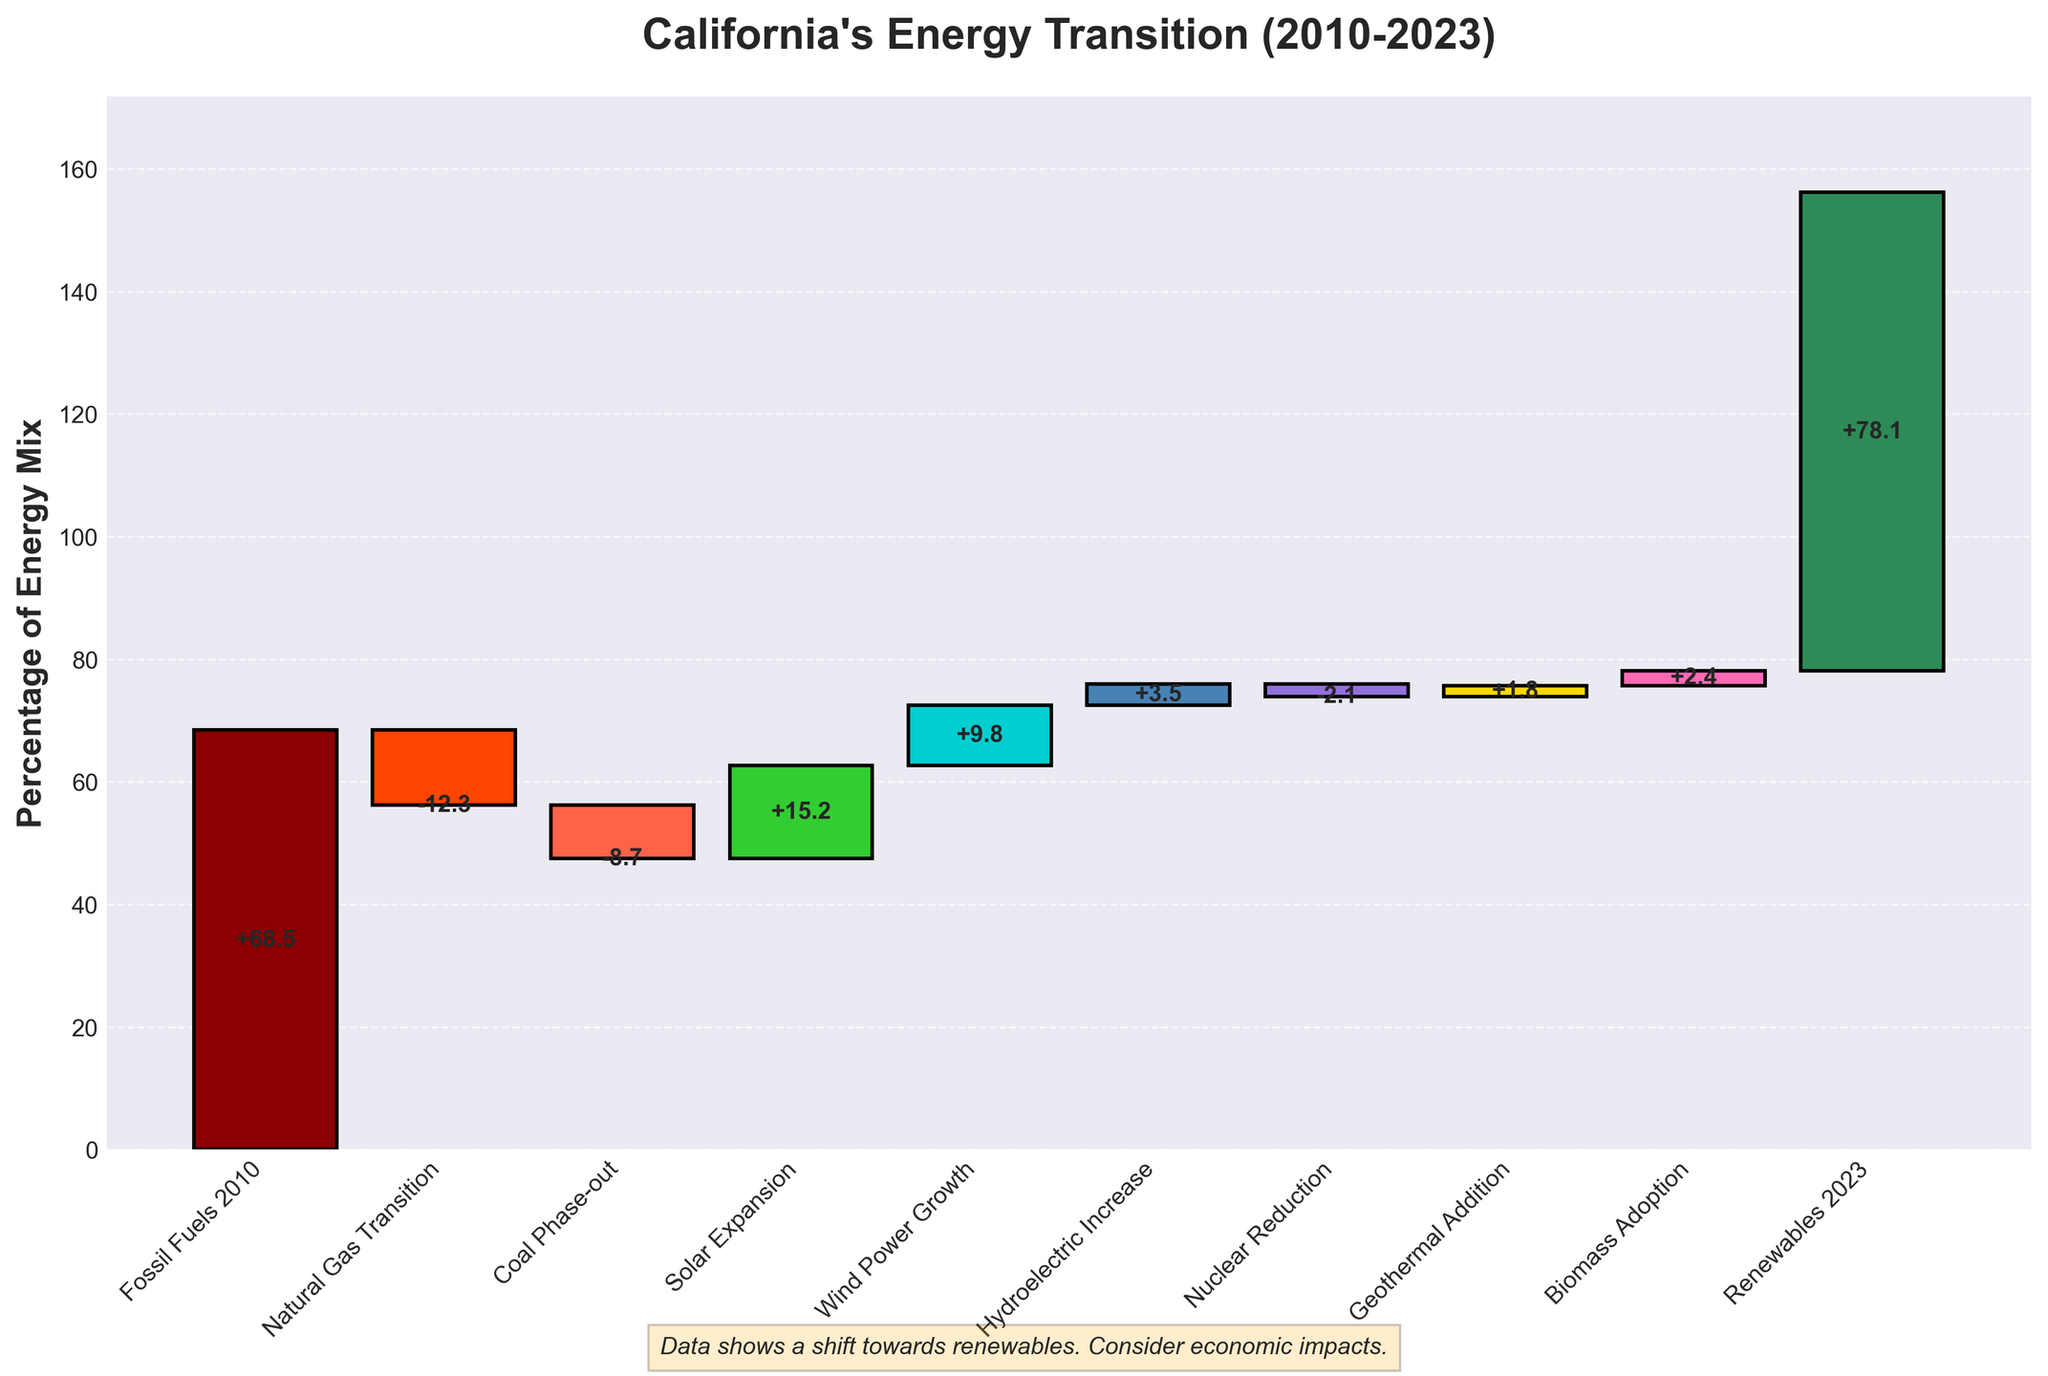What is the title of the chart? The chart title can be observed directly at the top; it's denoted in bold and larger font size.
Answer: California's Energy Transition (2010-2023) What is the value for Fossil Fuels in 2010? The value is next to the "Fossil Fuels 2010" category on the chart.
Answer: 68.5 Which energy source experienced the largest reduction? Identify the largest negative value on the chart and correlate it with the corresponding category.
Answer: Natural Gas Transition (-12.3) How much did renewable energy sources increase in total from 2010 to 2023? Summing the values of positive contributions labeled with renewable sources: (Solar Expansion 15.2 + Wind Power Growth 9.8 + Hydroelectric Increase 3.5 + Geothermal Addition 1.8 + Biomass Adoption 2.4) equals 32.7.
Answer: 32.7 What are the total negative adjustments? Add the negative values: Natural Gas Transition (-12.3) + Coal Phase-out (-8.7) + Nuclear Reduction (-2.1) equals -23.1.
Answer: -23.1 By how much did the value transition from Fossil Fuels 2010 to Renewables 2023? Subtract Fossil Fuels 2010 value from Renewables 2023 value: 78.1 - 68.5 = 9.6.
Answer: 9.6 Was there a net increase in energy from 2010 to 2023? Compare the initial 2010 value (68.5) to the final 2023 value (78.1) and note that 78.1 is greater than 68.5.
Answer: Yes Which renewable source had the smallest positive impact on the energy mix? Identify the smallest positive value among renewable sources: Geothermal Addition (1.8).
Answer: Geothermal Addition (1.8) How does the impact of Biomass Adoption compare to Nuclear Reduction in absolute value? Compare the absolute values: Biomass Adoption (2.4) vs. Nuclear Reduction (2.1). Since 2.4 is greater than 2.1, Biomass Adoption had a larger absolute impact.
Answer: Biomass Adoption had a larger impact What is the cumulative percentage end value shown in the plot, and how is it different from the starting value? The final cumulative percentage end value is next to "Renewables 2023." It starts from 68.5 (Fossil Fuels 2010) and reaches 78.1 (Renewables 2023). The difference is 78.1 - 68.5 = 9.6.
Answer: 78.1, 9.6 increase 